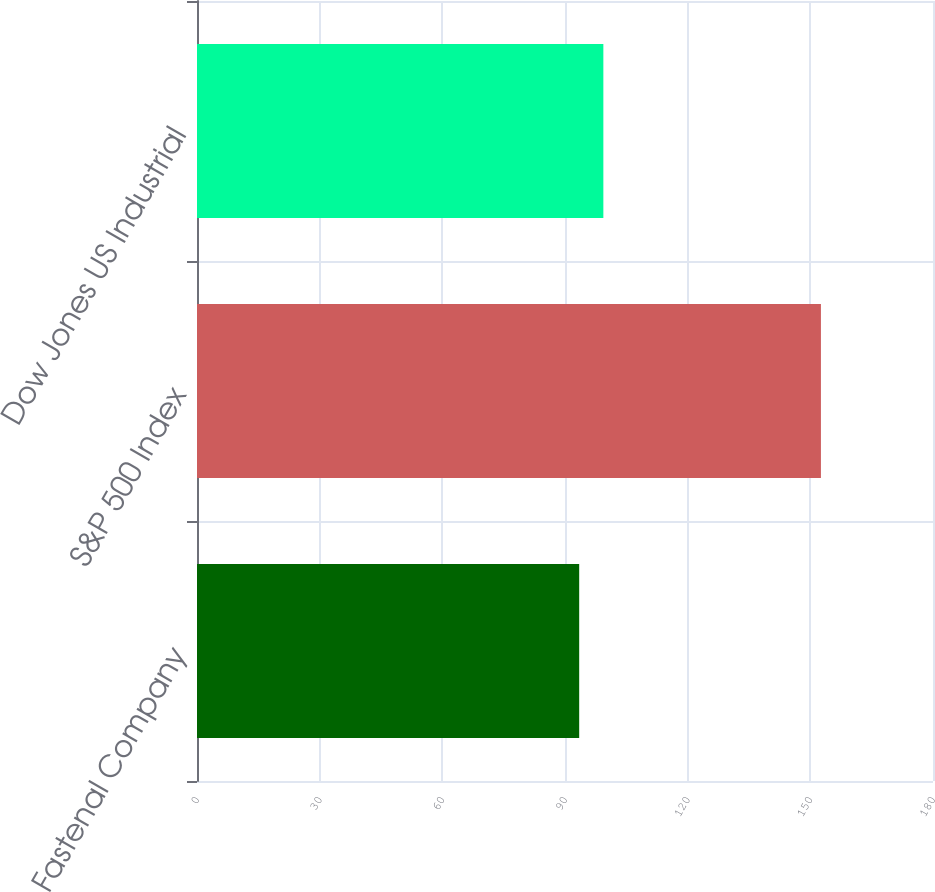Convert chart to OTSL. <chart><loc_0><loc_0><loc_500><loc_500><bar_chart><fcel>Fastenal Company<fcel>S&P 500 Index<fcel>Dow Jones US Industrial<nl><fcel>93.47<fcel>152.59<fcel>99.38<nl></chart> 